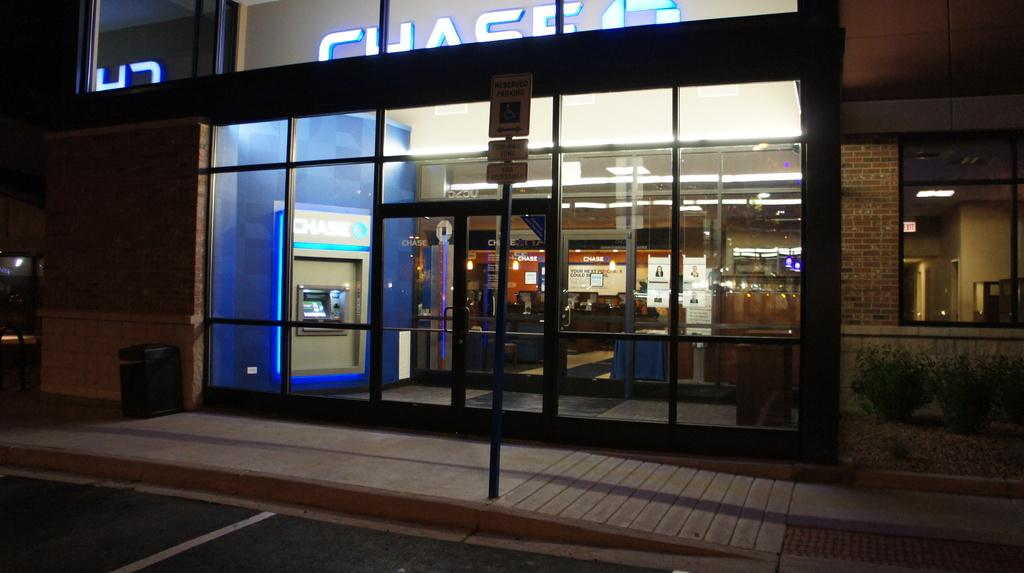What type of structure is present in the image? There is a building in the image. What can be seen illuminated in the image? There are lights visible in the image. What type of entrance is present in the building? There are glass doors in the image. What is located directly in front of the building? There is a dustbin in front of the building. What type of information might be conveyed by the sign board in front of the building? The sign board in front of the building might convey information about the building or its surroundings. How far away is the coach from the building in the image? There is no coach present in the image, so it is not possible to determine the distance between a coach and the building. 